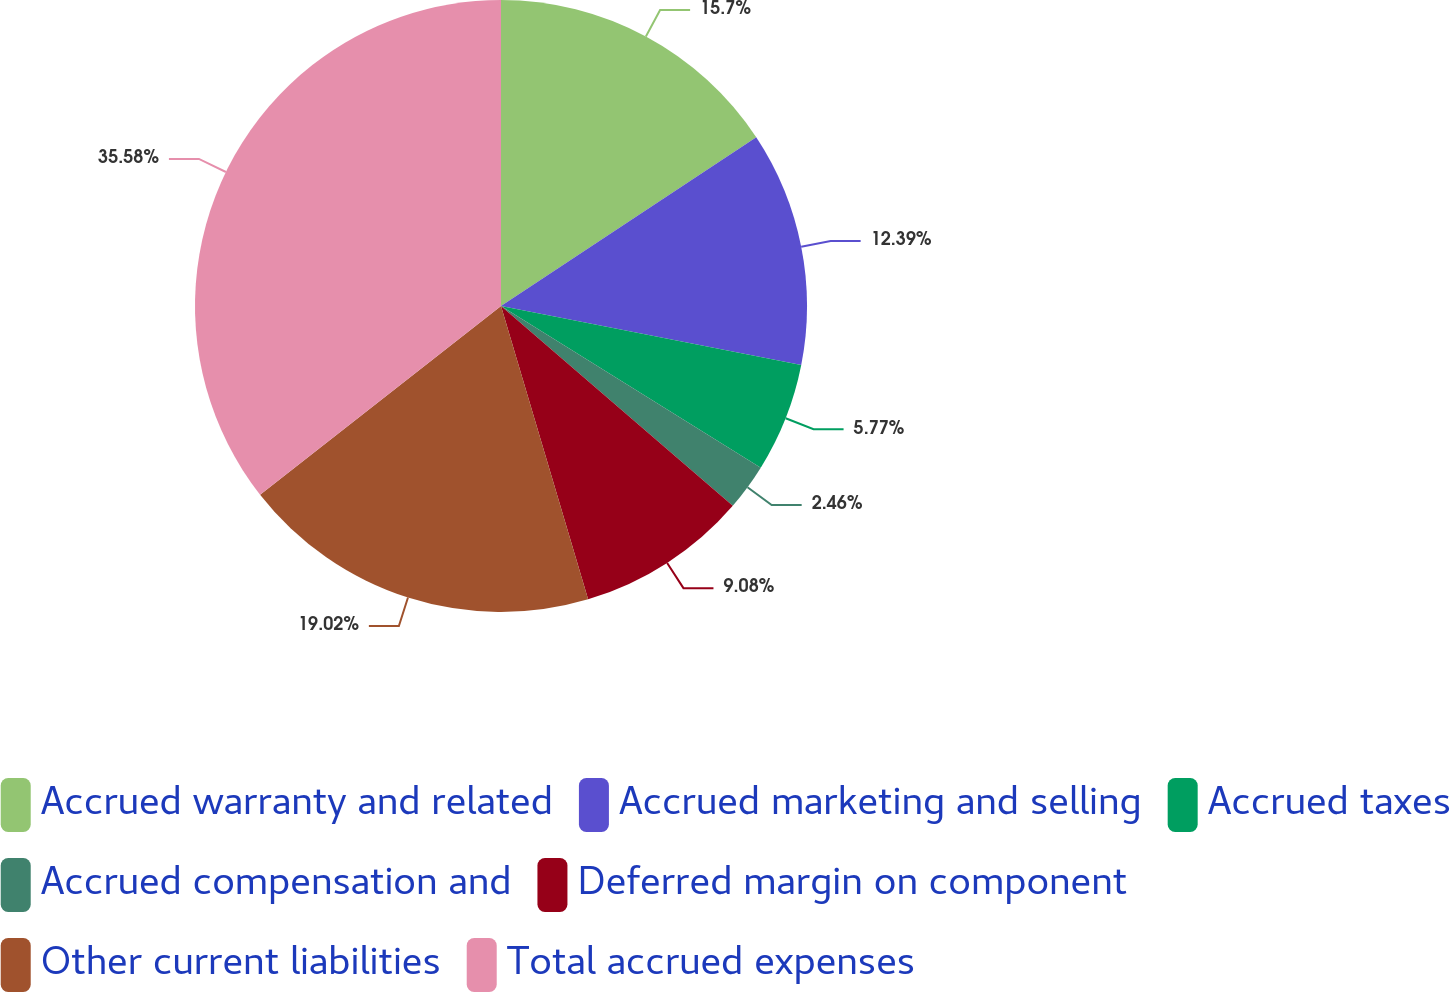<chart> <loc_0><loc_0><loc_500><loc_500><pie_chart><fcel>Accrued warranty and related<fcel>Accrued marketing and selling<fcel>Accrued taxes<fcel>Accrued compensation and<fcel>Deferred margin on component<fcel>Other current liabilities<fcel>Total accrued expenses<nl><fcel>15.7%<fcel>12.39%<fcel>5.77%<fcel>2.46%<fcel>9.08%<fcel>19.02%<fcel>35.57%<nl></chart> 